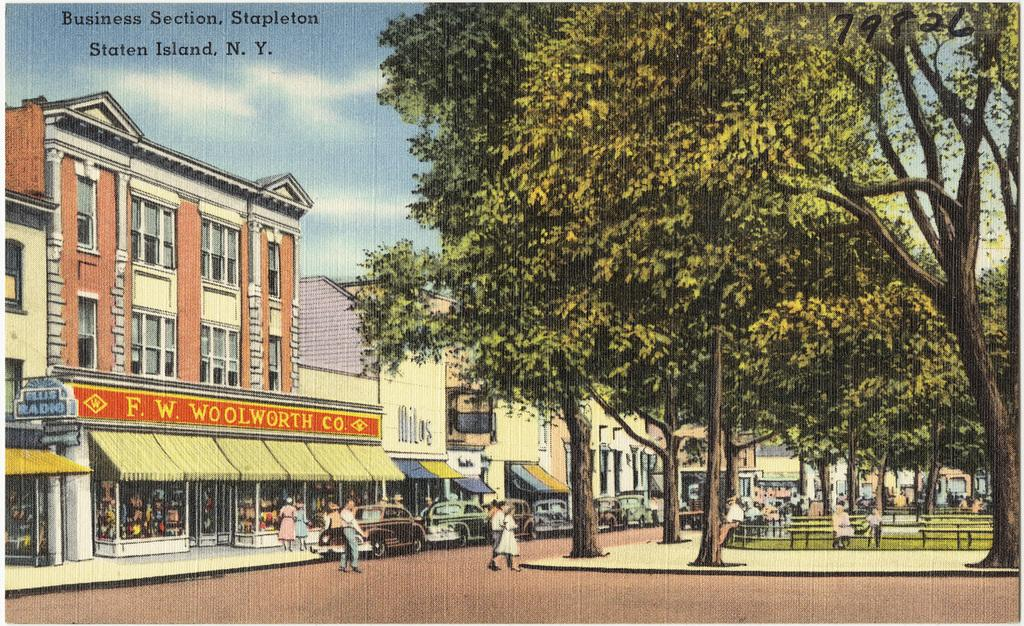What type of artwork is the image? The image is a painting. What structures are depicted in the painting? There are buildings in the painting. What type of vegetation is present in the painting? There are trees in the painting. What type of seating is available in the painting? There are benches in the painting. Who or what is present in the painting? There are people in the painting. What mode of transportation is visible in the painting? There are cars in the painting. What part of the natural environment is visible in the painting? There is sky visible in the background of the painting. Are there any words or letters present in the painting? Yes, there is text present in the painting. What type of sticks are being used by the pet in the painting? There is no pet present in the painting, and therefore no sticks being used by a pet. 